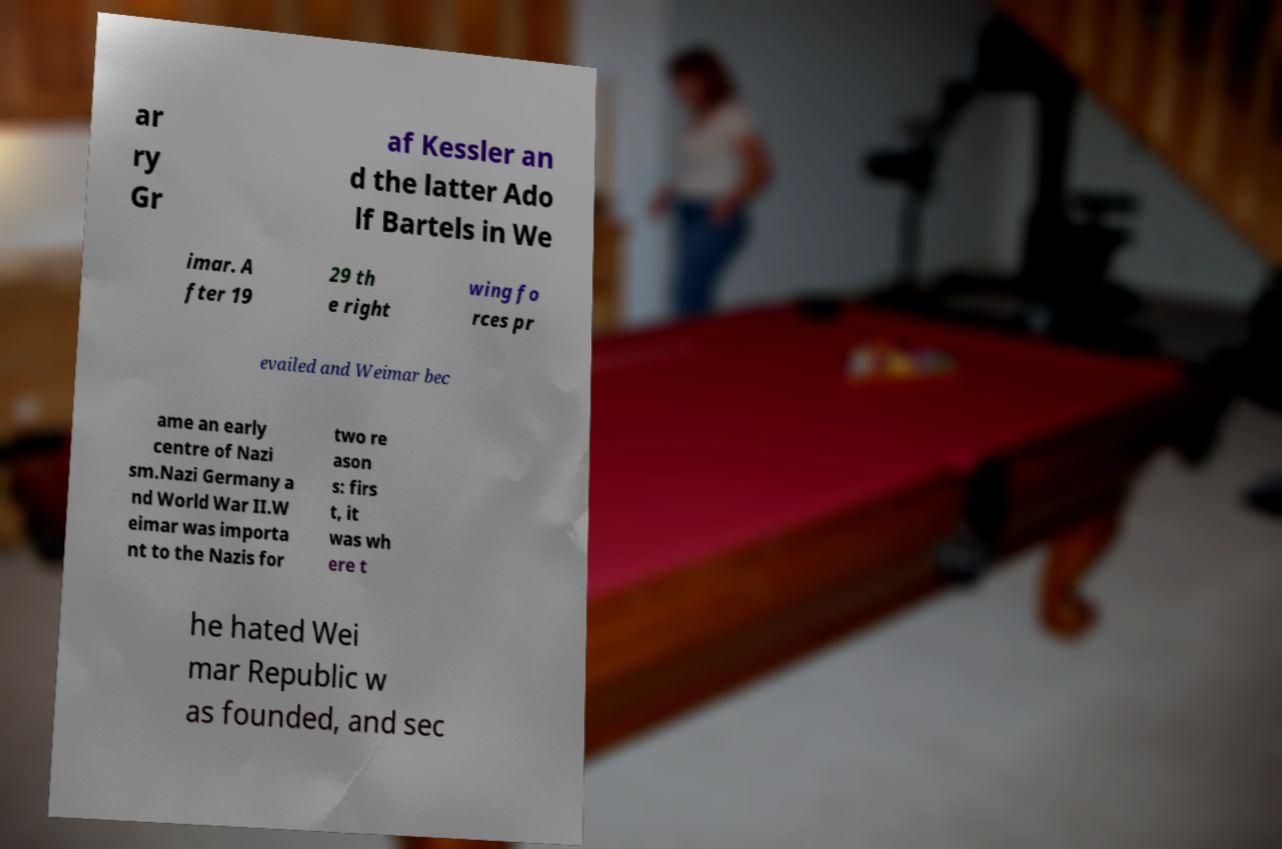Can you read and provide the text displayed in the image?This photo seems to have some interesting text. Can you extract and type it out for me? ar ry Gr af Kessler an d the latter Ado lf Bartels in We imar. A fter 19 29 th e right wing fo rces pr evailed and Weimar bec ame an early centre of Nazi sm.Nazi Germany a nd World War II.W eimar was importa nt to the Nazis for two re ason s: firs t, it was wh ere t he hated Wei mar Republic w as founded, and sec 